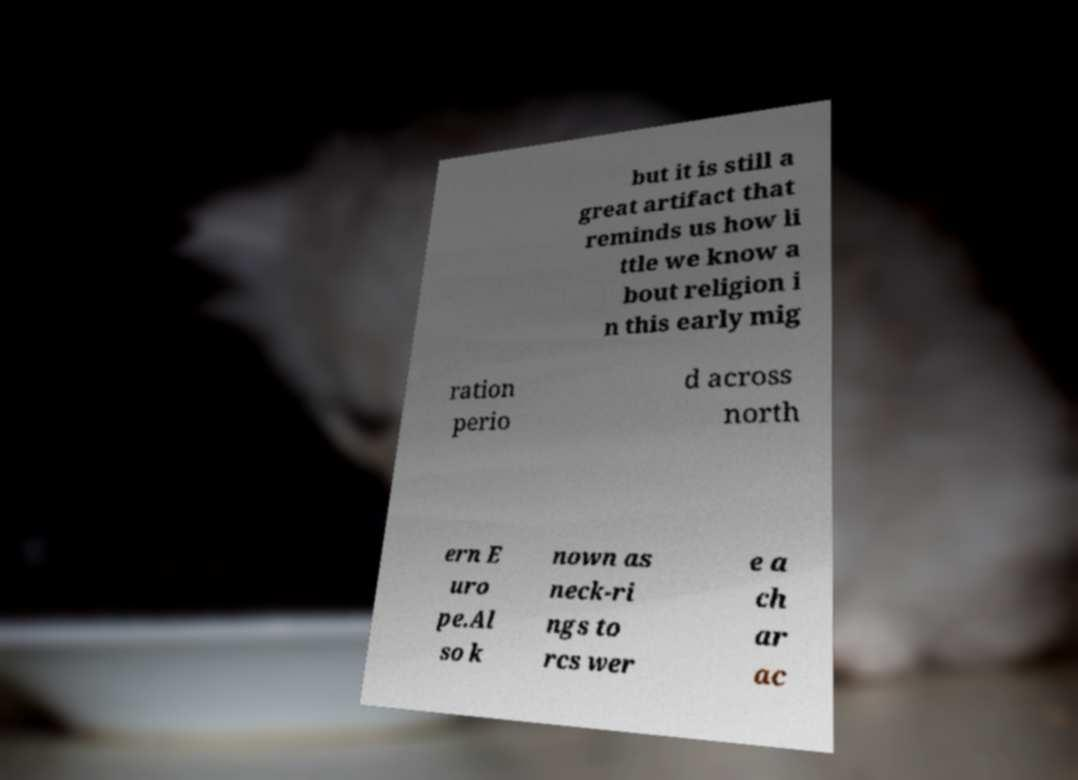What messages or text are displayed in this image? I need them in a readable, typed format. but it is still a great artifact that reminds us how li ttle we know a bout religion i n this early mig ration perio d across north ern E uro pe.Al so k nown as neck-ri ngs to rcs wer e a ch ar ac 